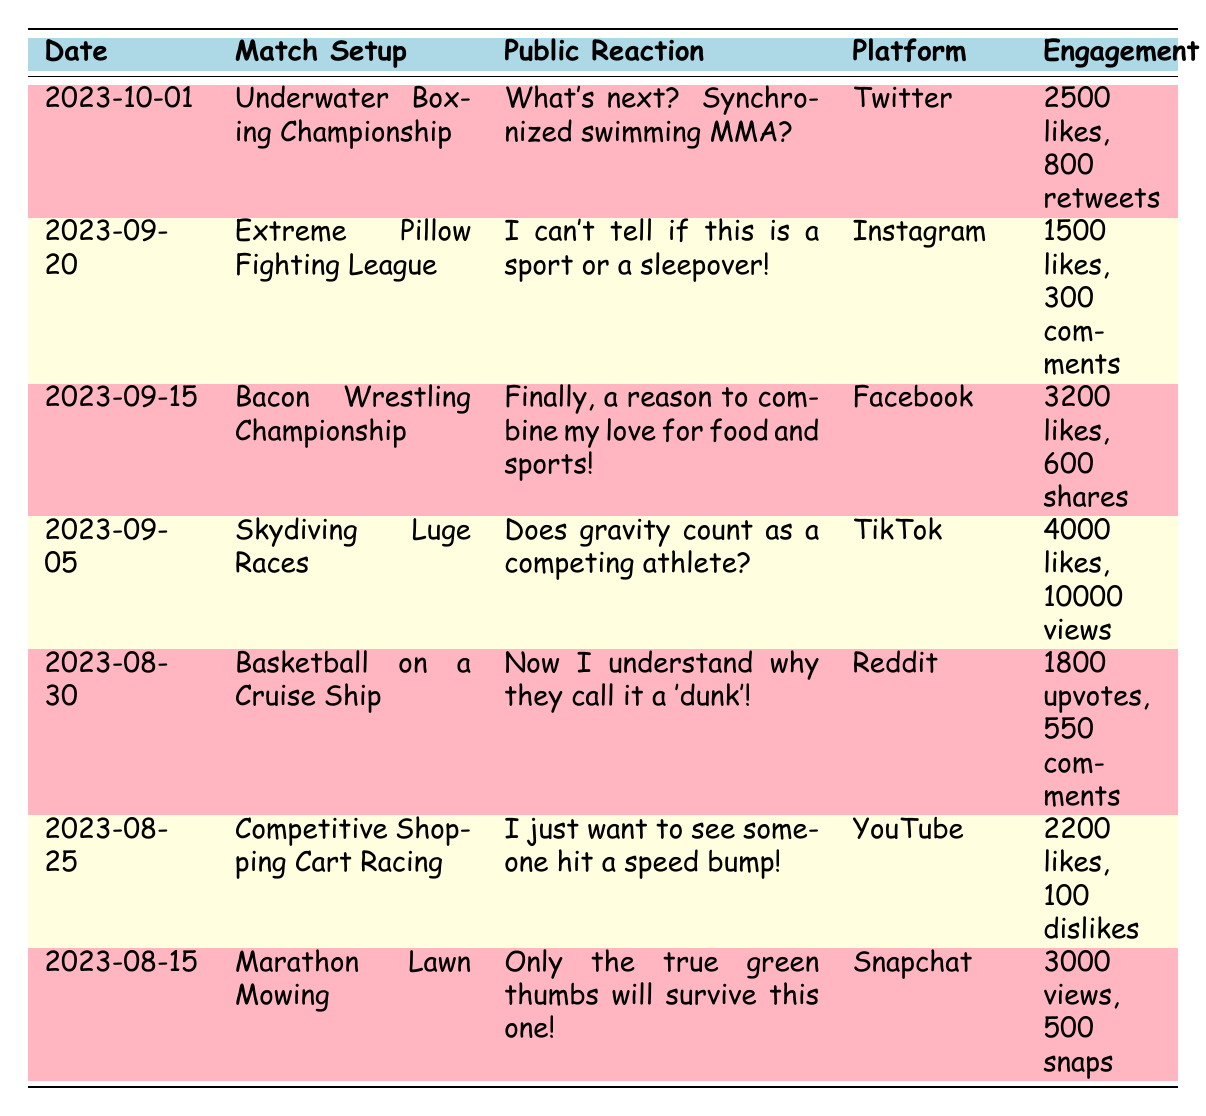What is the public reaction to the Extreme Pillow Fighting League? The public reaction to the Extreme Pillow Fighting League stated, "I can’t tell if this is a sport or a sleepover!"
Answer: I can’t tell if this is a sport or a sleepover! Which match setup received the highest number of likes? The match setup that received the highest number of likes is the Skydiving Luge Races with 4000 likes.
Answer: Skydiving Luge Races Is there a match setup on social media that included a food reference? Yes, the Bacon Wrestling Championship includes a food reference as noted by the reaction: "Finally, a reason to combine my love for food and sports!"
Answer: Yes What is the total engagement for the Underwater Boxing Championship? The total engagement for the Underwater Boxing Championship can be calculated as 2500 likes + 800 retweets = 3300 engagements.
Answer: 3300 Which platform had the lowest engagement? To find the lowest engagement, we compare the available metrics: Underwater Boxing Championship (3300), Extreme Pillow Fighting League (1500), Bacon Wrestling Championship (3200), Skydiving Luge Races (4000), Basketball on a Cruise Ship (2350), Competitive Shopping Cart Racing (2200), and Marathon Lawn Mowing (3000). The Extreme Pillow Fighting League had the lowest engagement at 1500.
Answer: Extreme Pillow Fighting League How many views did the Marathon Lawn Mowing receive? The Marathon Lawn Mowing received 3000 views, as indicated in the table.
Answer: 3000 Which match setup was discussed on YouTube and what was the public reaction? The match setup discussed on YouTube was Competitive Shopping Cart Racing, and the public reaction was, "I just want to see someone hit a speed bump!"
Answer: Competitive Shopping Cart Racing, "I just want to see someone hit a speed bump!" What was the combined number of snaps and views for Marathon Lawn Mowing? The combined figures for Marathon Lawn Mowing are 3000 views + 500 snaps = 3500 combined.
Answer: 3500 How many dates are listed for public reactions to the match setups? There are 7 dates listed for the public reactions to the match setups.
Answer: 7 